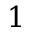Convert formula to latex. <formula><loc_0><loc_0><loc_500><loc_500>1</formula> 